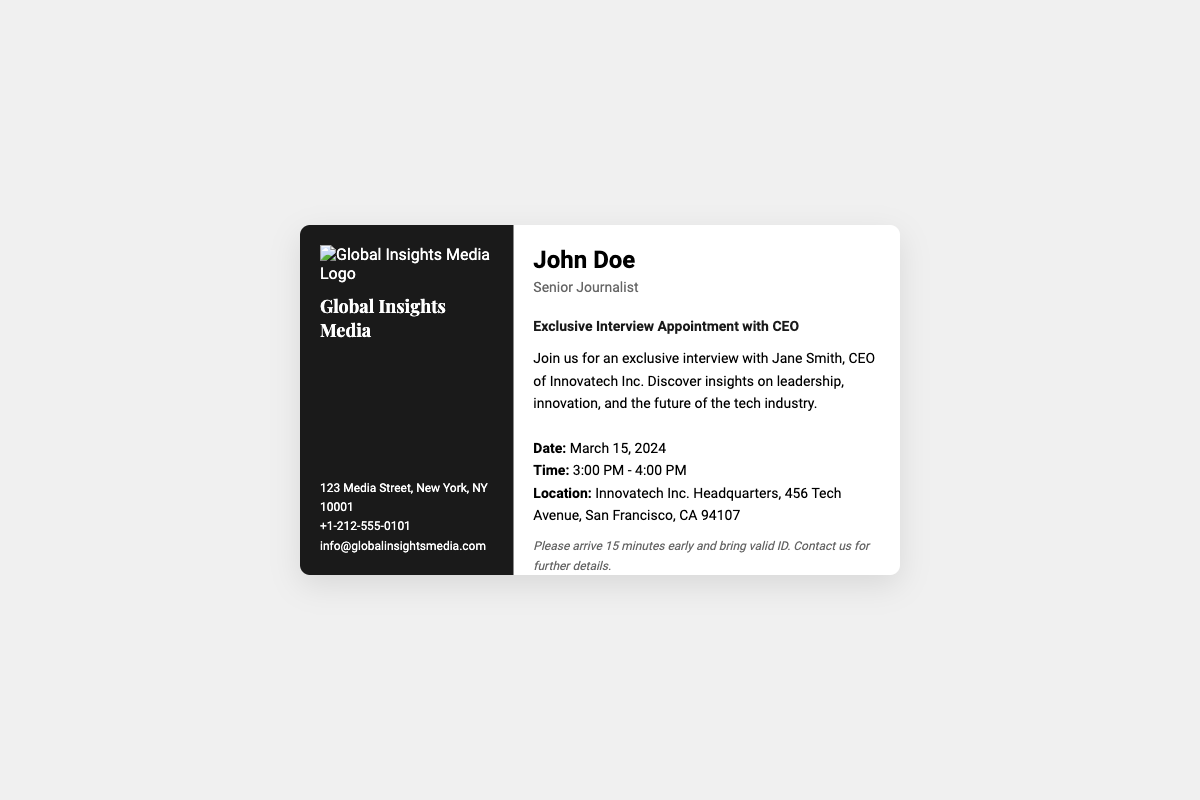What is the name of the CEO being interviewed? The document states the CEO's name as Jane Smith, who is the CEO of Innovatech Inc.
Answer: Jane Smith What is the date of the exclusive interview? The document provides the date for the exclusive interview, which is mentioned as March 15, 2024.
Answer: March 15, 2024 What time does the interview start? The document specifies that the interview starts at 3:00 PM.
Answer: 3:00 PM Where is the location of the interview? The document includes the location of the interview, which is Innovatech Inc. Headquarters, 456 Tech Avenue, San Francisco, CA 94107.
Answer: Innovatech Inc. Headquarters, 456 Tech Avenue, San Francisco, CA 94107 What is the name of the journalist conducting the interview? The document identifies the journalist conducting the interview as John Doe.
Answer: John Doe What is the role of the journalist? The document indicates the journalist's designation as Senior Journalist.
Answer: Senior Journalist How early should attendees arrive before the interview? The document advises attendees to arrive 15 minutes early.
Answer: 15 minutes What should attendees bring to the interview? The document mentions that attendees should bring valid ID.
Answer: Valid ID What is the website for Global Insights Media? The document states the website for Global Insights Media as www.globalinsightsmedia.com.
Answer: www.globalinsightsmedia.com 